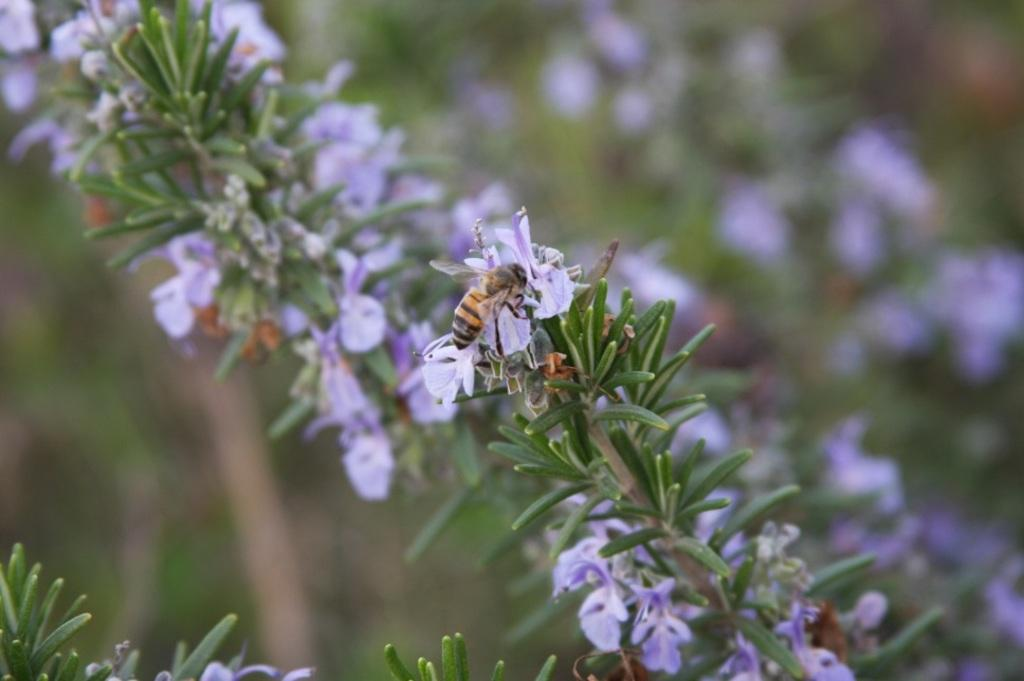What type of living organisms can be seen in the image? Plants and flowers are visible in the image. Is there any interaction between the plants and animals in the image? Yes, there is a bee on a flower in the image. What type of cup can be seen in the image? There is no cup present in the image. Is there a tank visible in the image? There is no tank present in the image. 